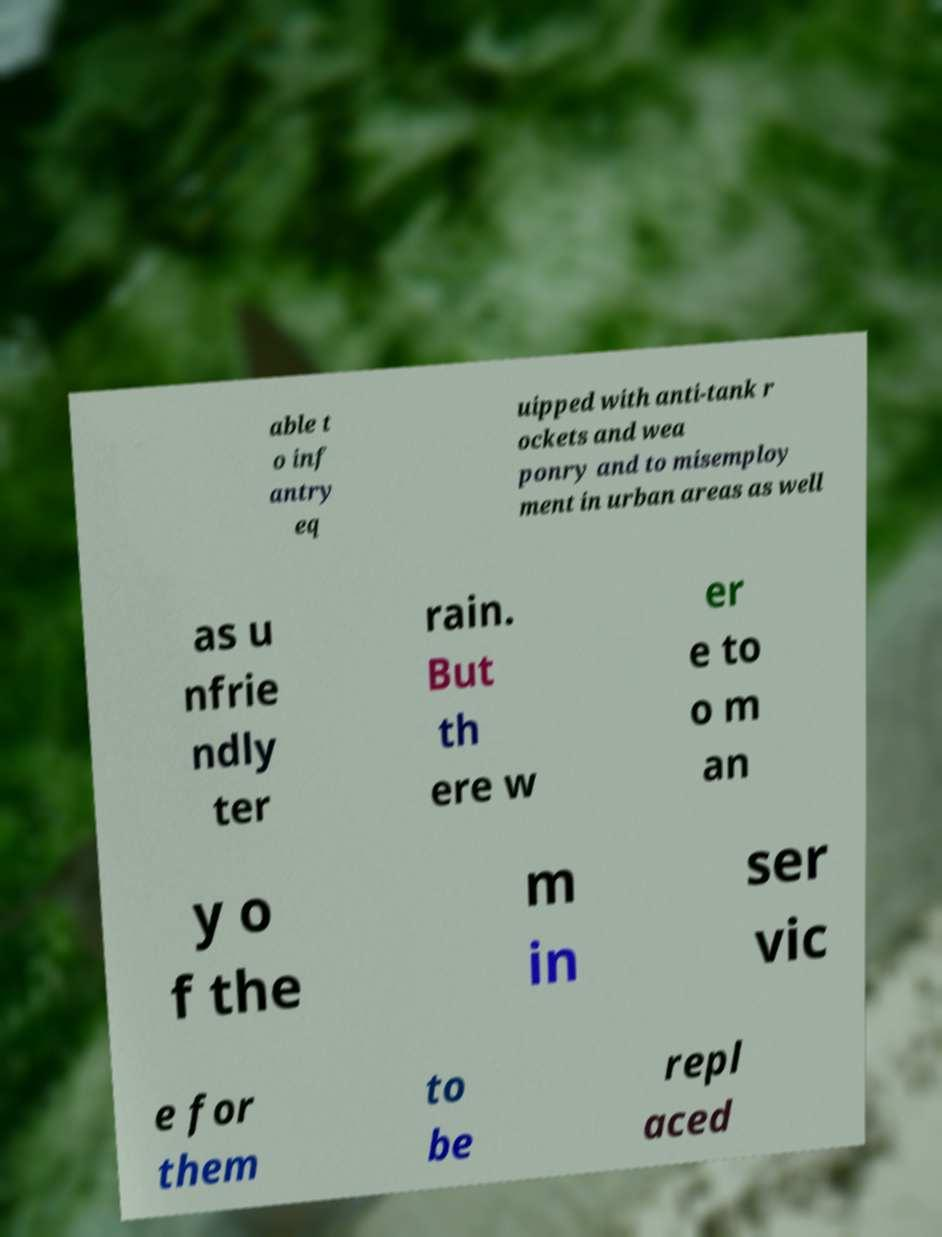I need the written content from this picture converted into text. Can you do that? able t o inf antry eq uipped with anti-tank r ockets and wea ponry and to misemploy ment in urban areas as well as u nfrie ndly ter rain. But th ere w er e to o m an y o f the m in ser vic e for them to be repl aced 